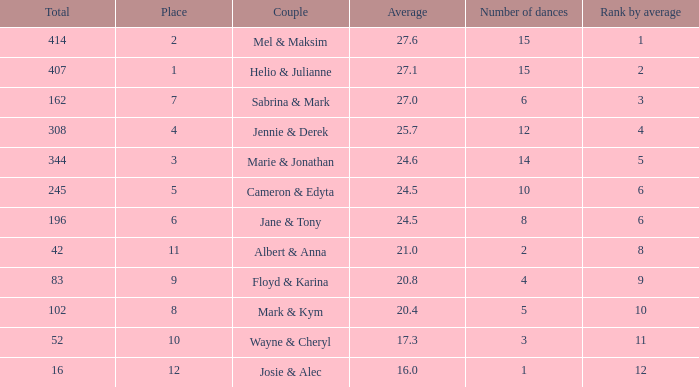What is the average when the rank by average is more than 12? None. 